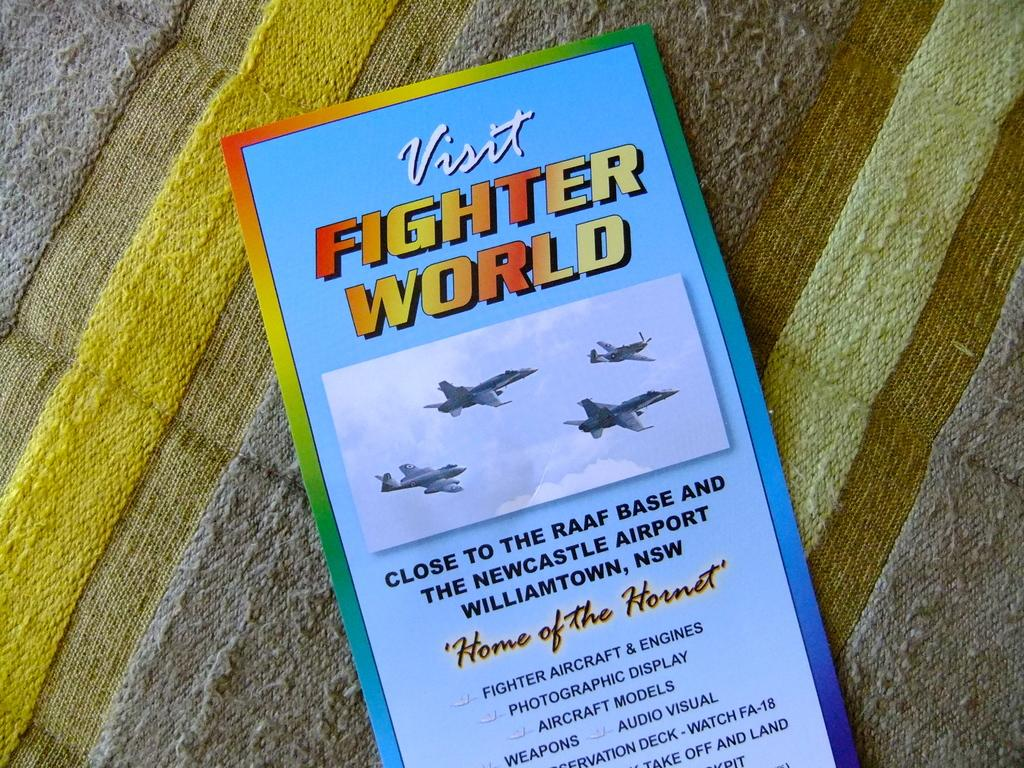<image>
Give a short and clear explanation of the subsequent image. A brochure that says Visit Fighter World in yellow and red letters with info about it underneath a picture of 4 airplanes. 